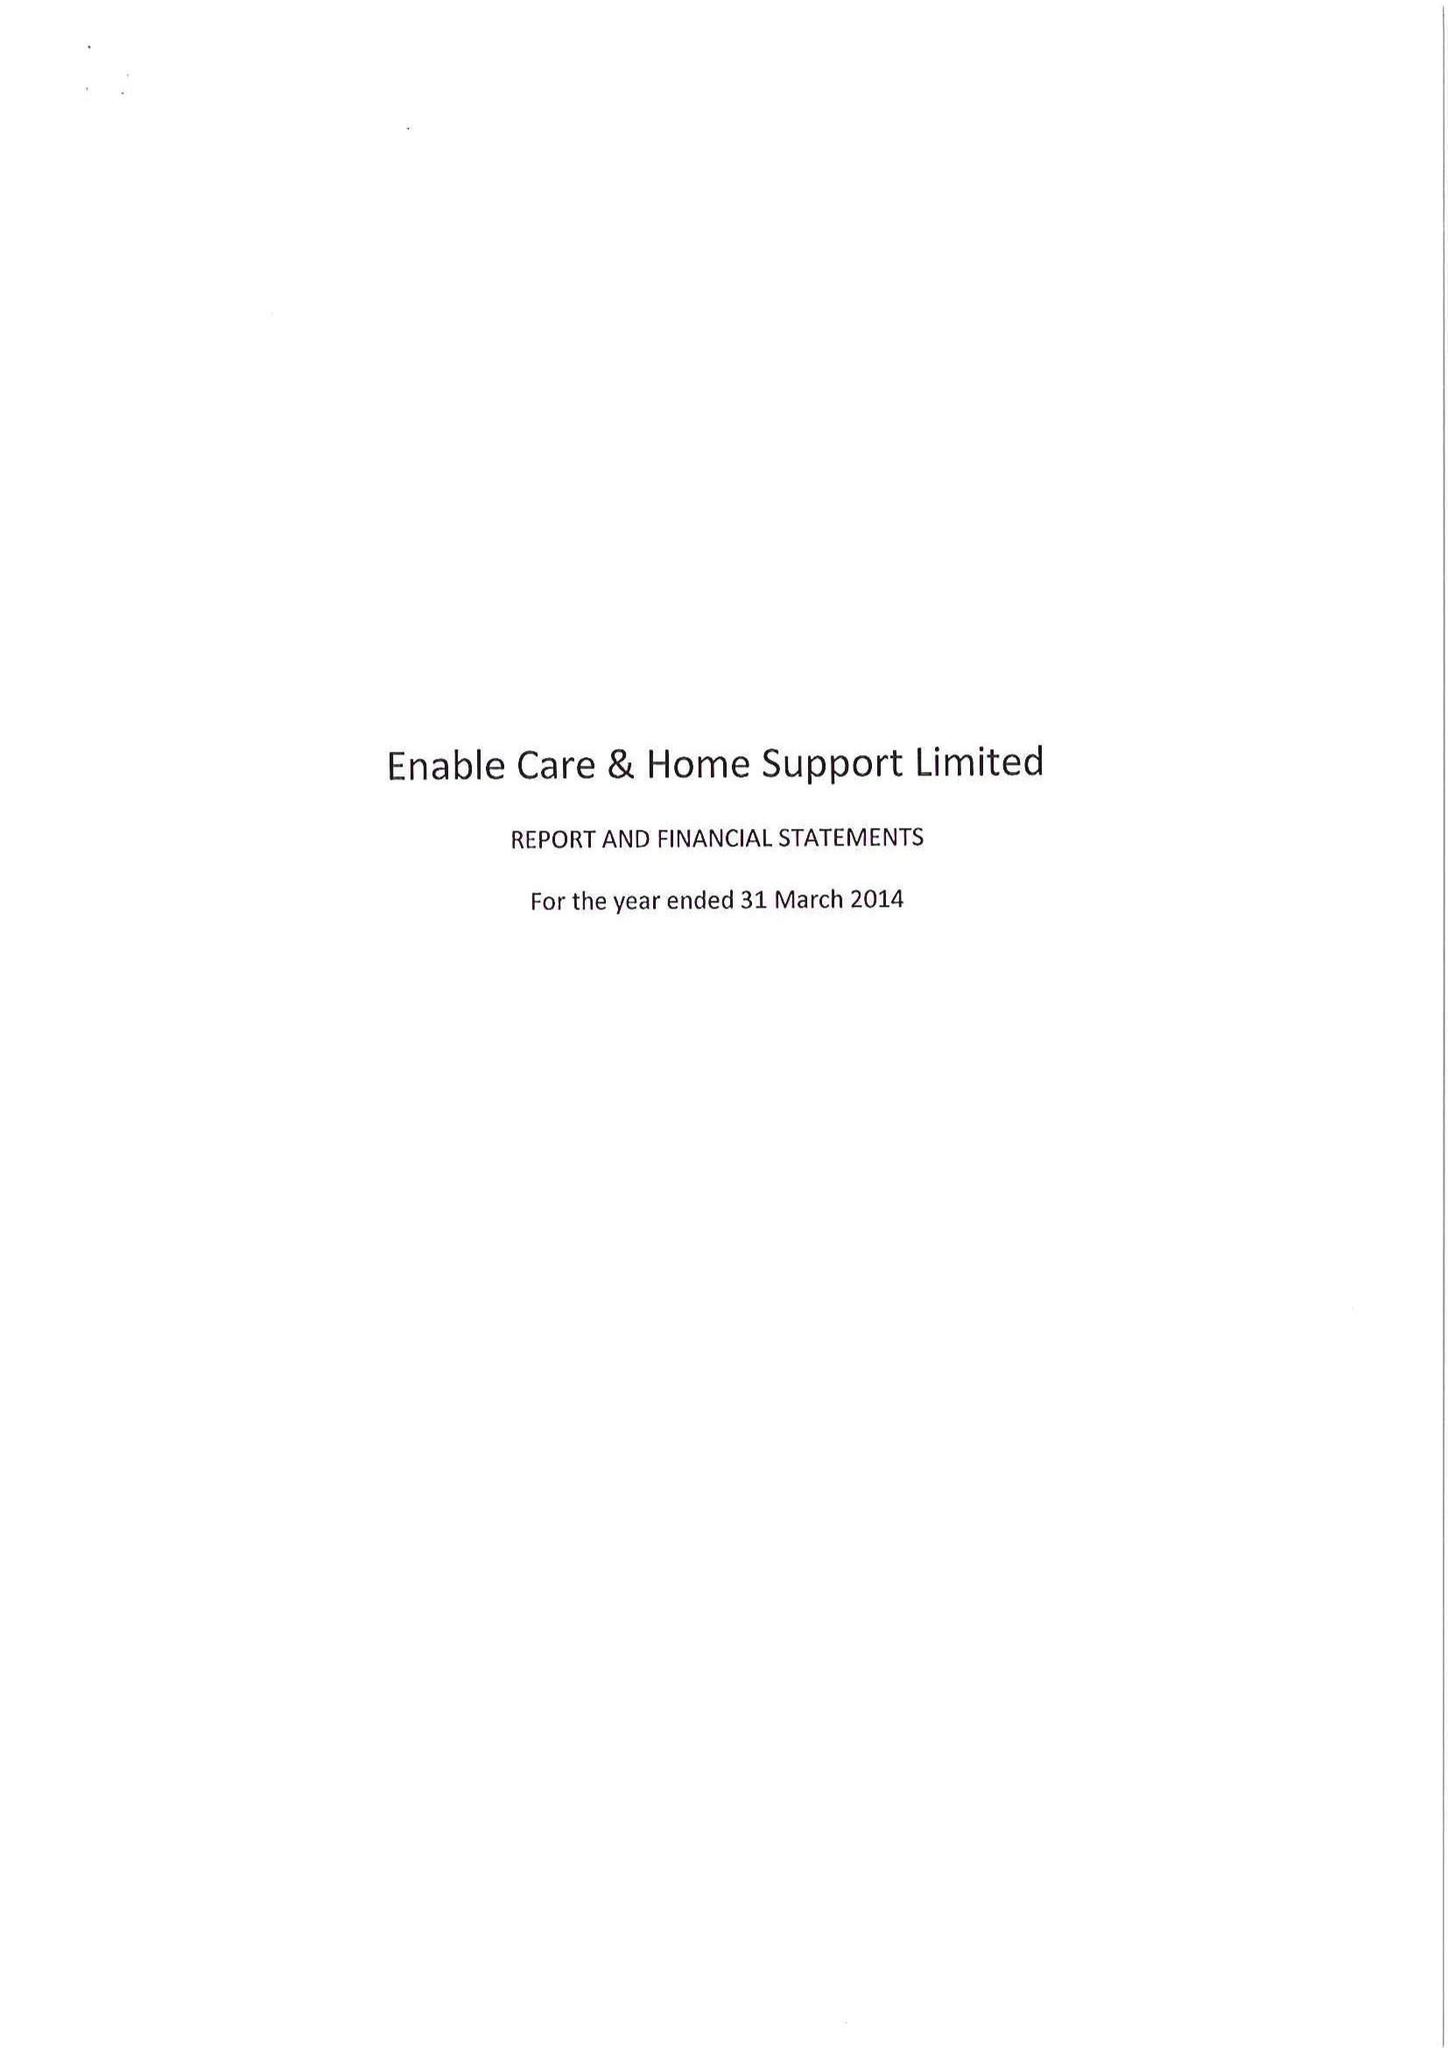What is the value for the address__post_town?
Answer the question using a single word or phrase. COALVILLE 